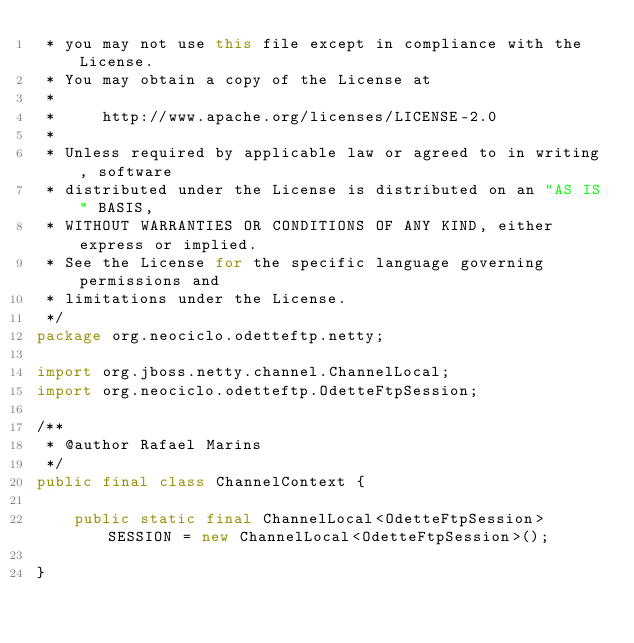<code> <loc_0><loc_0><loc_500><loc_500><_Java_> * you may not use this file except in compliance with the License.
 * You may obtain a copy of the License at
 *
 *     http://www.apache.org/licenses/LICENSE-2.0
 *
 * Unless required by applicable law or agreed to in writing, software
 * distributed under the License is distributed on an "AS IS" BASIS,
 * WITHOUT WARRANTIES OR CONDITIONS OF ANY KIND, either express or implied.
 * See the License for the specific language governing permissions and
 * limitations under the License.
 */
package org.neociclo.odetteftp.netty;

import org.jboss.netty.channel.ChannelLocal;
import org.neociclo.odetteftp.OdetteFtpSession;

/**
 * @author Rafael Marins
 */
public final class ChannelContext {

    public static final ChannelLocal<OdetteFtpSession> SESSION = new ChannelLocal<OdetteFtpSession>();

}
</code> 